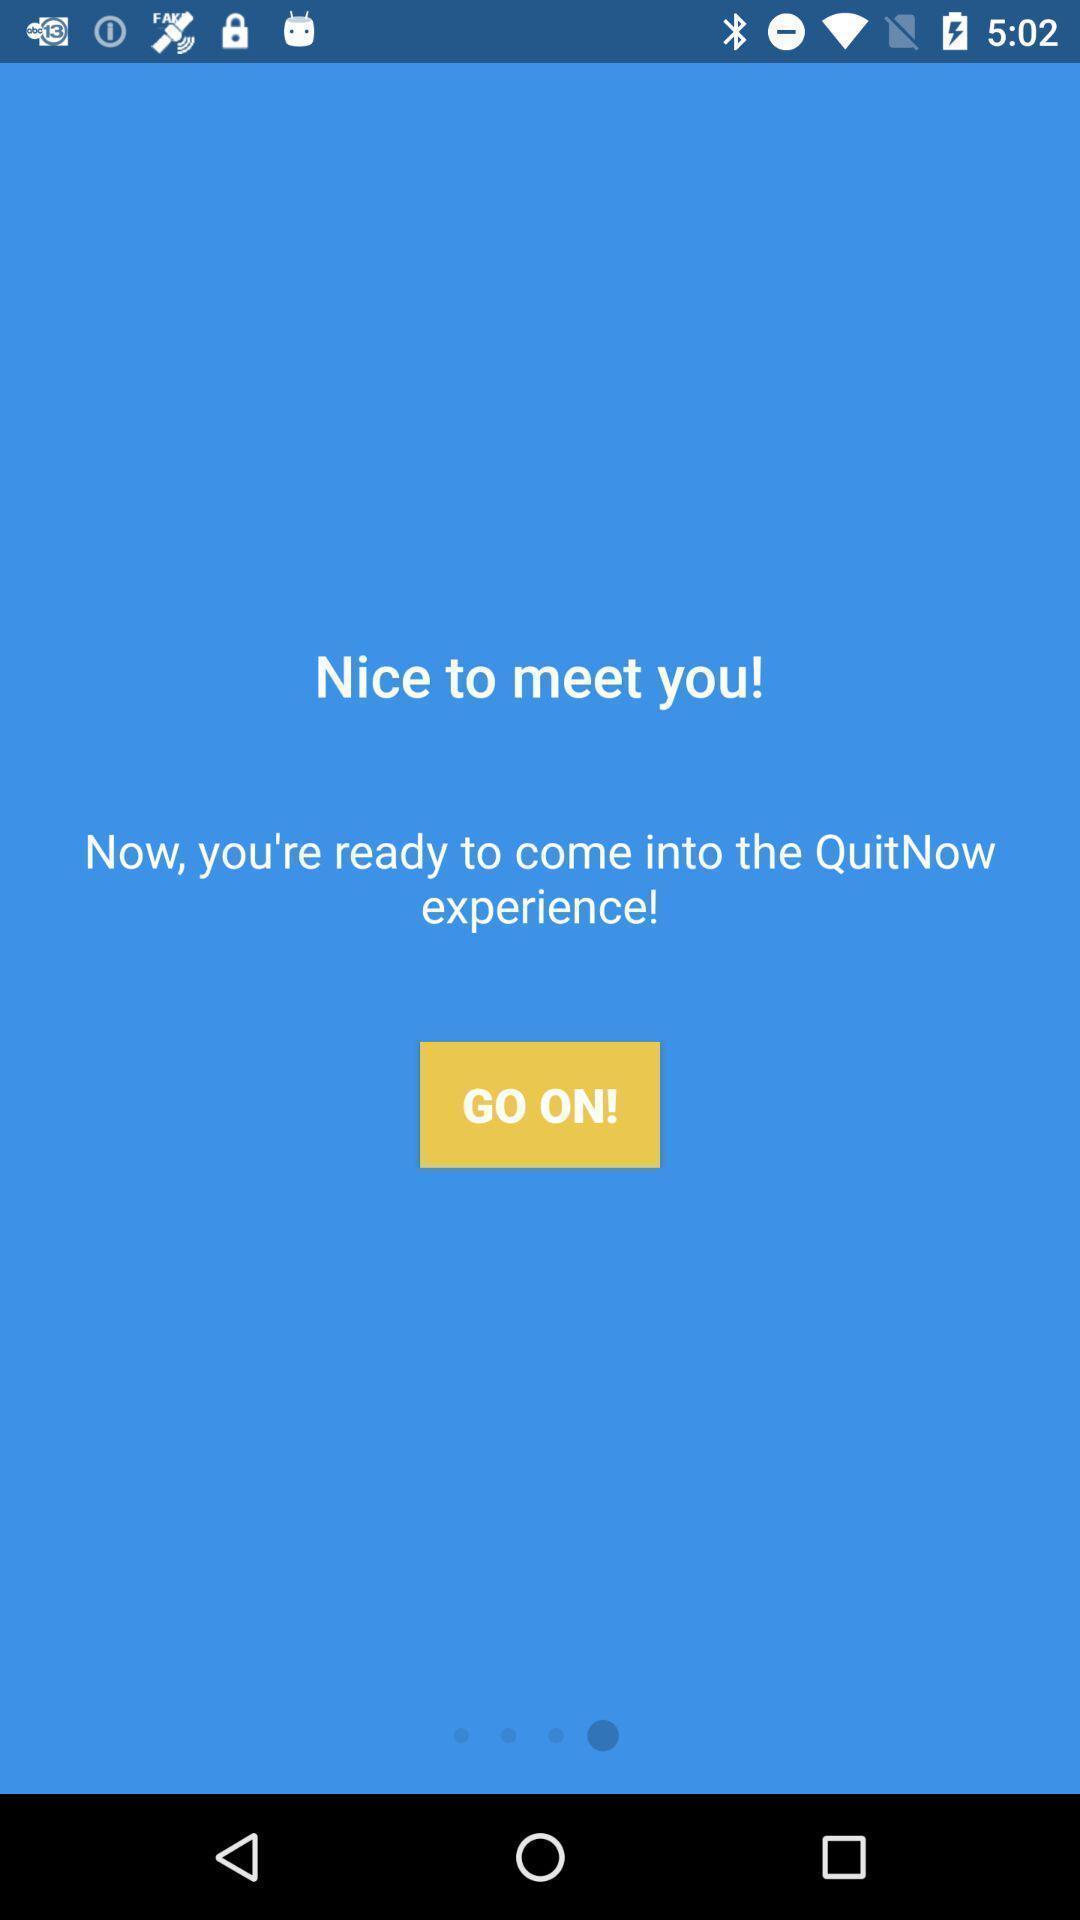Provide a description of this screenshot. Welcome page of a new app. 